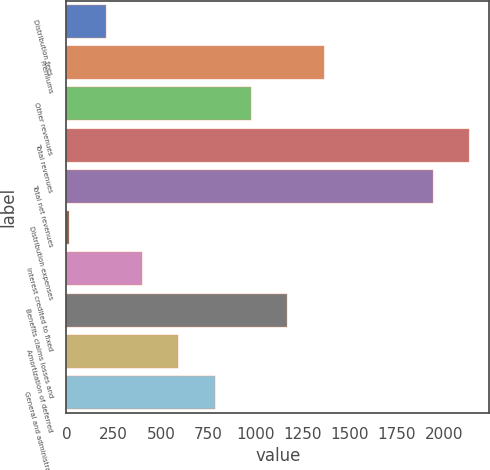Convert chart. <chart><loc_0><loc_0><loc_500><loc_500><bar_chart><fcel>Distribution fees<fcel>Premiums<fcel>Other revenues<fcel>Total revenues<fcel>Total net revenues<fcel>Distribution expenses<fcel>Interest credited to fixed<fcel>Benefits claims losses and<fcel>Amortization of deferred<fcel>General and administrative<nl><fcel>208.4<fcel>1362.8<fcel>978<fcel>2131.4<fcel>1939<fcel>16<fcel>400.8<fcel>1170.4<fcel>593.2<fcel>785.6<nl></chart> 